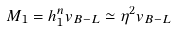<formula> <loc_0><loc_0><loc_500><loc_500>M _ { 1 } = h ^ { n } _ { 1 } v _ { B - L } \simeq \eta ^ { 2 } v _ { B - L }</formula> 